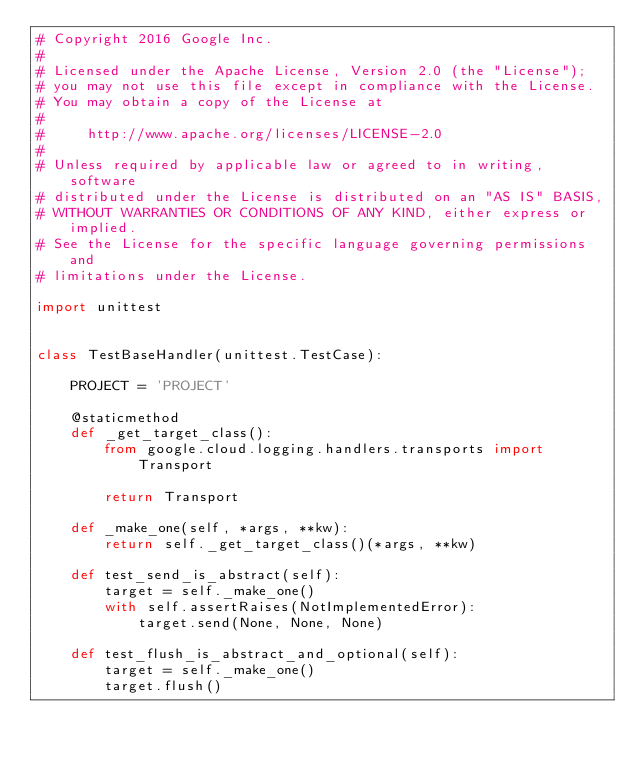<code> <loc_0><loc_0><loc_500><loc_500><_Python_># Copyright 2016 Google Inc.
#
# Licensed under the Apache License, Version 2.0 (the "License");
# you may not use this file except in compliance with the License.
# You may obtain a copy of the License at
#
#     http://www.apache.org/licenses/LICENSE-2.0
#
# Unless required by applicable law or agreed to in writing, software
# distributed under the License is distributed on an "AS IS" BASIS,
# WITHOUT WARRANTIES OR CONDITIONS OF ANY KIND, either express or implied.
# See the License for the specific language governing permissions and
# limitations under the License.

import unittest


class TestBaseHandler(unittest.TestCase):

    PROJECT = 'PROJECT'

    @staticmethod
    def _get_target_class():
        from google.cloud.logging.handlers.transports import Transport

        return Transport

    def _make_one(self, *args, **kw):
        return self._get_target_class()(*args, **kw)

    def test_send_is_abstract(self):
        target = self._make_one()
        with self.assertRaises(NotImplementedError):
            target.send(None, None, None)

    def test_flush_is_abstract_and_optional(self):
        target = self._make_one()
        target.flush()
</code> 